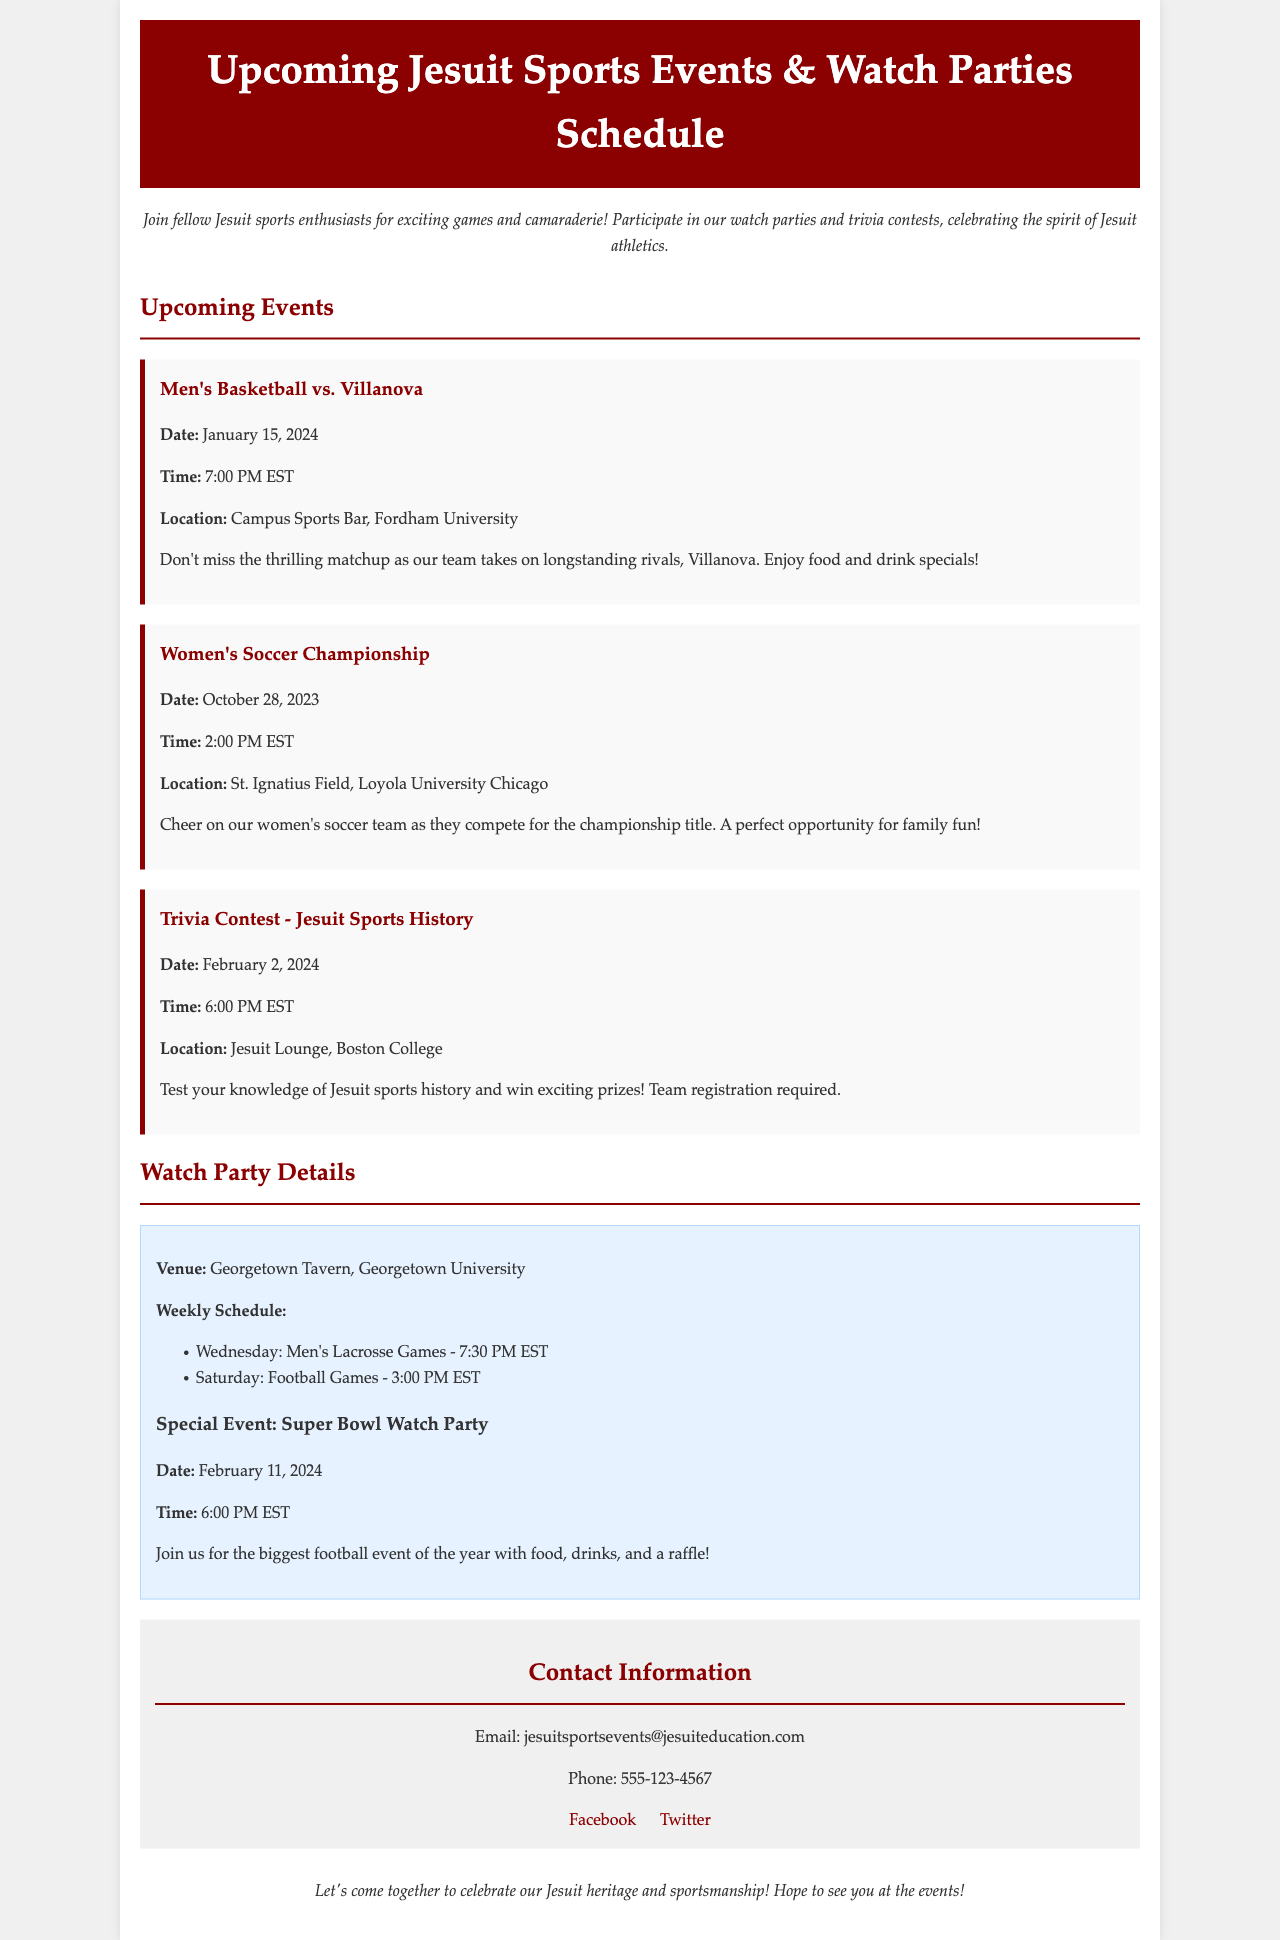What is the date of the Men's Basketball game? The date for the Men's Basketball game is provided in the document under the event details.
Answer: January 15, 2024 Where is the Women's Soccer Championship taking place? The location of the Women's Soccer Championship is mentioned in the event information.
Answer: St. Ignatius Field, Loyola University Chicago What is the time of the Trivia Contest? The time for the Trivia Contest is specified in the event details.
Answer: 6:00 PM EST What special event is mentioned for February 11, 2024? The document explicitly states a special event occurring on this date.
Answer: Super Bowl Watch Party How often are Men's Lacrosse games held at the watch party venue? The frequency of Men's Lacrosse games is listed under the watch party schedule.
Answer: Weekly on Wednesday How many events are scheduled for February 2024? To determine the number, the document lists events by their dates; February has two events described.
Answer: 2 Which venue hosts the weekly watch parties? The venue for the watch parties is mentioned in the watch party details section.
Answer: Georgetown Tavern, Georgetown University What type of contest is planned for February 2, 2024? The contest type is specified in the event details section of the document.
Answer: Trivia Contest - Jesuit Sports History 